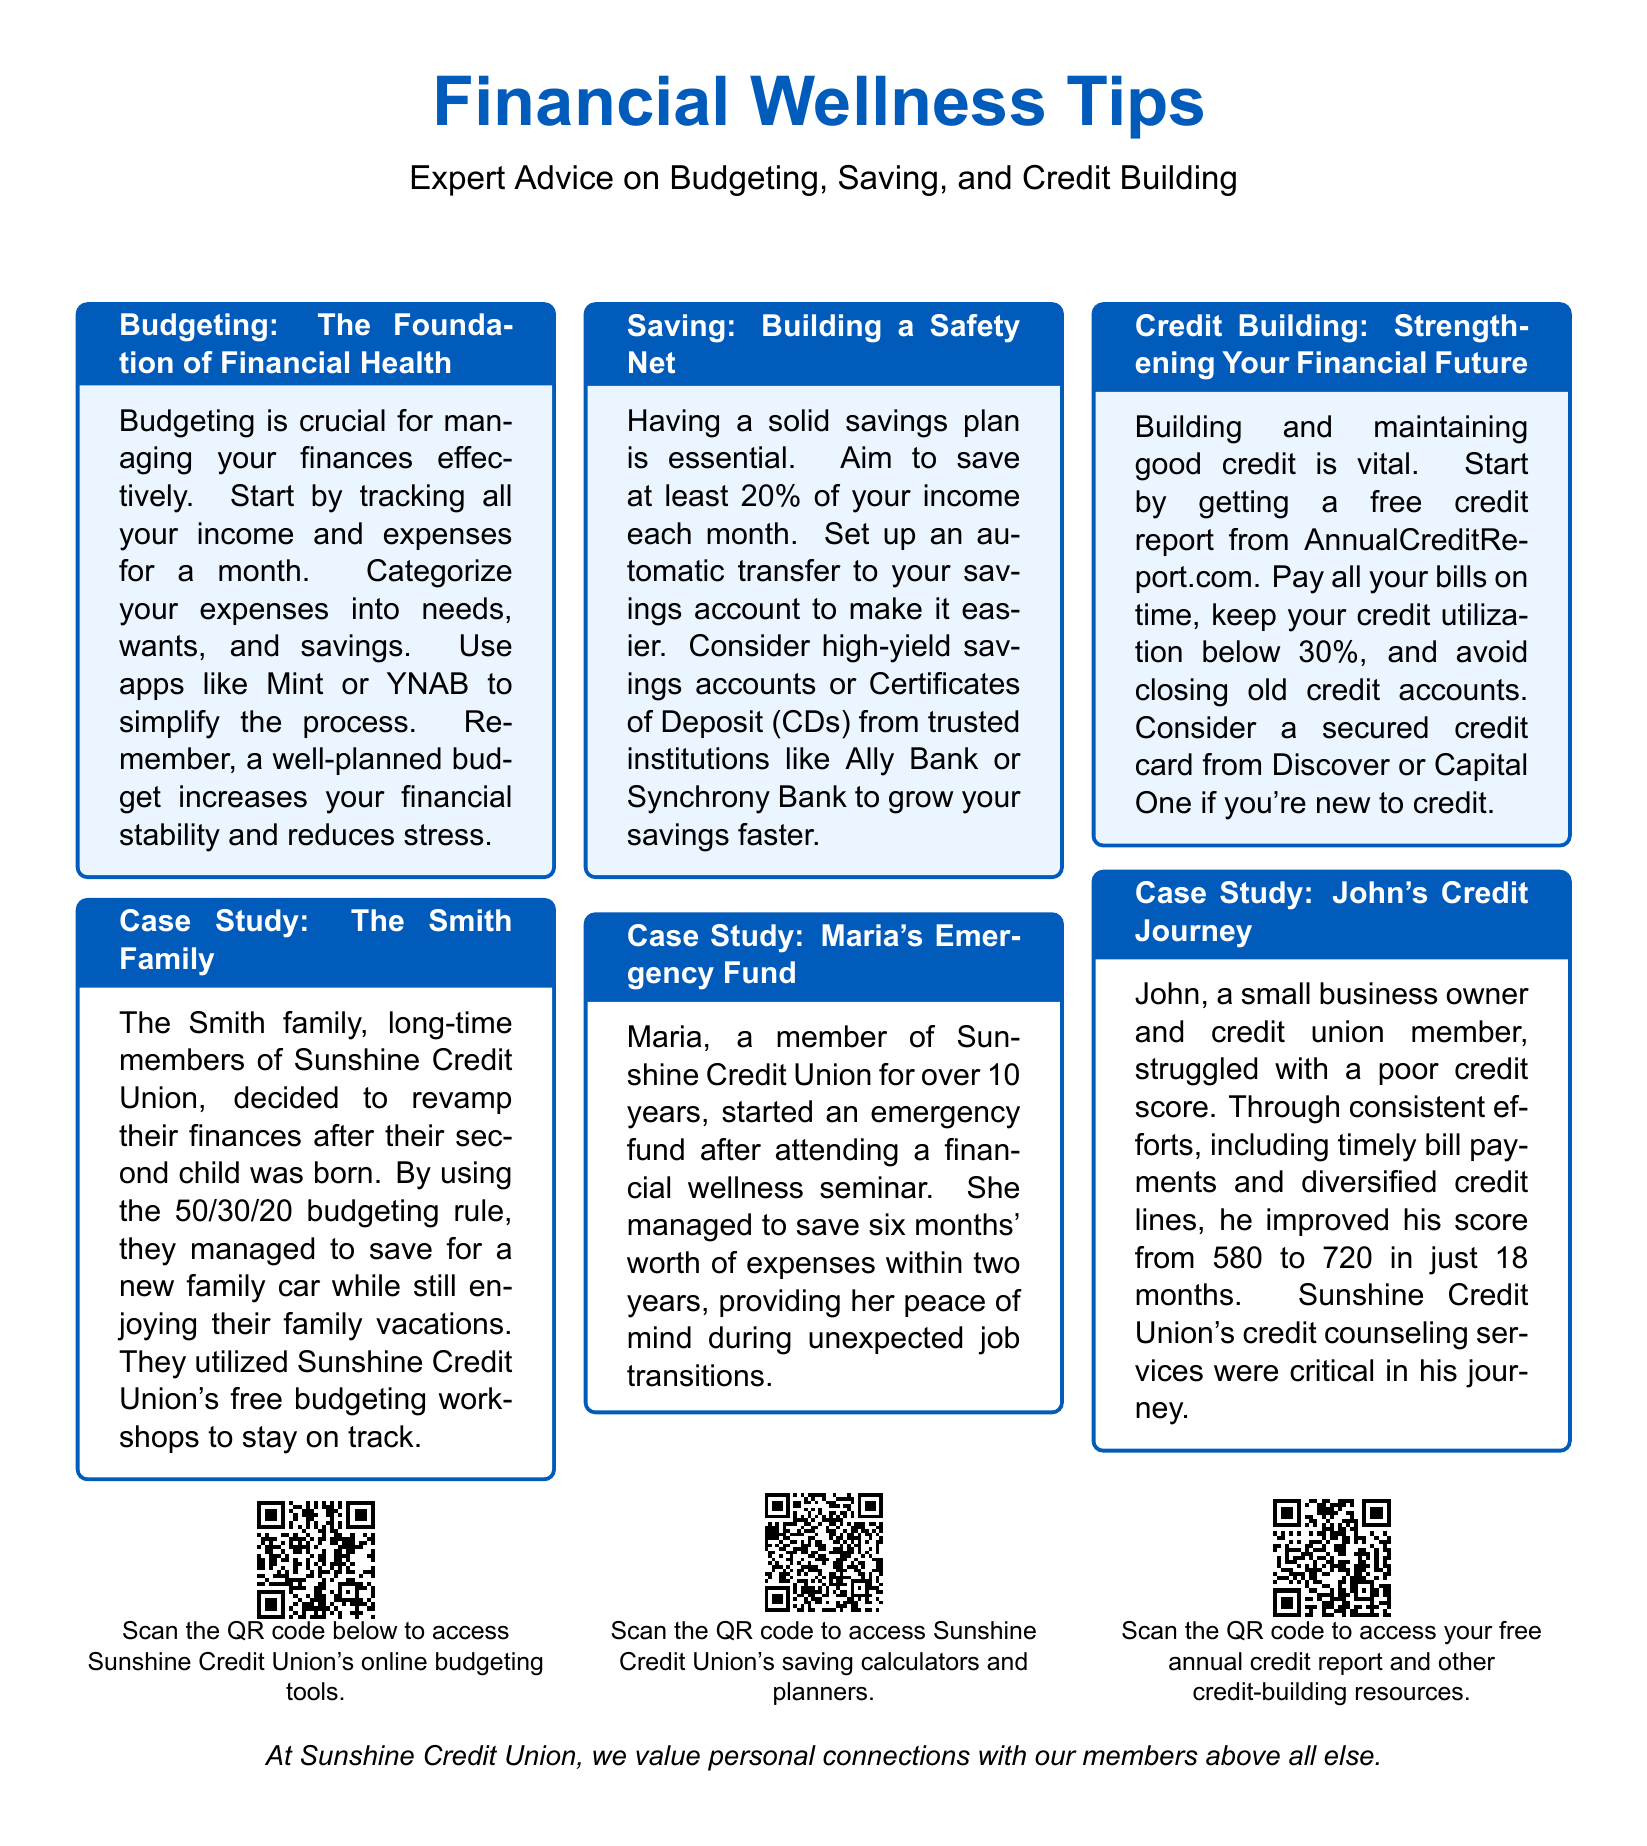What is the title of the first section? The title of the first section is provided at the top of the first tcolorbox under the heading.
Answer: Budgeting: The Foundation of Financial Health How much should you aim to save each month? This information can be found in the second section under the Saving topic.
Answer: 20% What was the Smith family's goal for their new budget? The goal of the Smith family was to save for a new family car while still enjoying vacations.
Answer: save for a new family car What resources does Sunshine Credit Union offer for budgeting? The document mentions specific workshops provided by Sunshine Credit Union that assist members with budgeting.
Answer: free budgeting workshops How did John improve his credit score? The document describes John's consistent efforts, which collectively contributed to improving his credit score.
Answer: timely bill payments and diversified credit lines What is Maria's achievement in terms of savings? The document highlights Maria's savings milestone over two years in the second case study.
Answer: six months' worth of expenses What is the link provided to access savings calculators? The link to access Sunshine Credit Union's saving calculators is stated below the Saving section.
Answer: https://www.sunshinecu.org/savings-calculators What is the purpose of the QR codes included? The QR codes serve as a means to access additional online resources related to each financial topic.
Answer: access additional online resources 